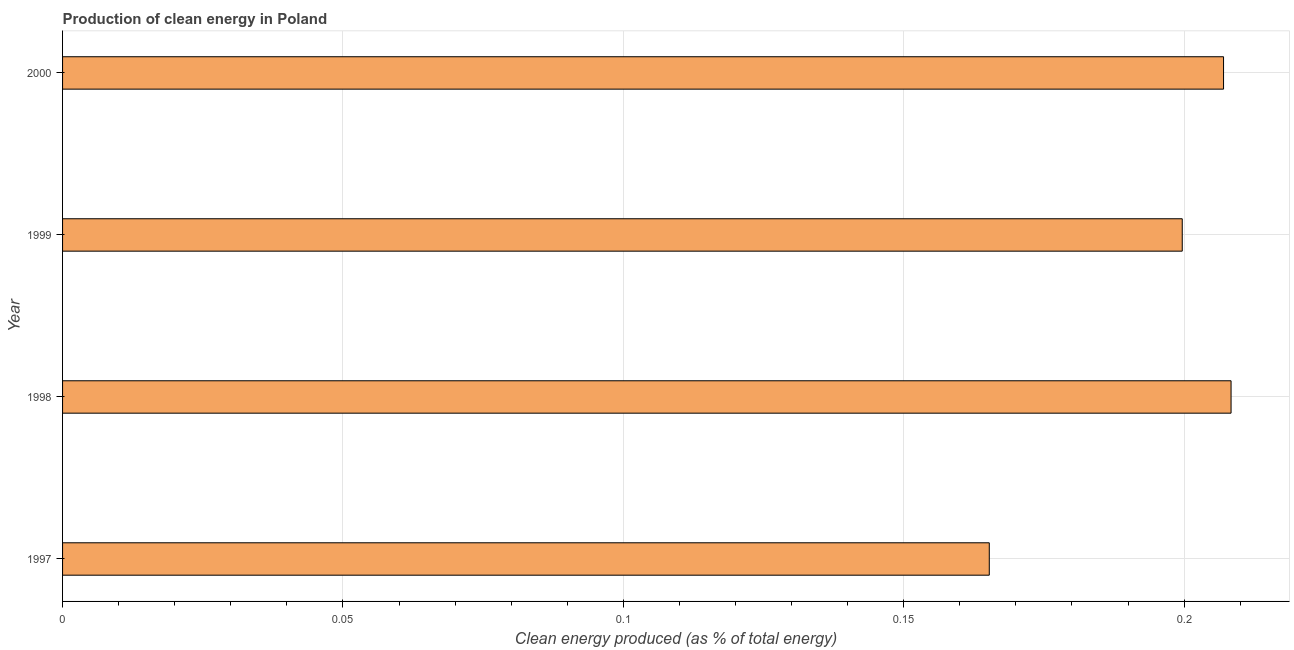Does the graph contain grids?
Make the answer very short. Yes. What is the title of the graph?
Ensure brevity in your answer.  Production of clean energy in Poland. What is the label or title of the X-axis?
Your answer should be compact. Clean energy produced (as % of total energy). What is the label or title of the Y-axis?
Provide a succinct answer. Year. What is the production of clean energy in 1998?
Your answer should be very brief. 0.21. Across all years, what is the maximum production of clean energy?
Ensure brevity in your answer.  0.21. Across all years, what is the minimum production of clean energy?
Your answer should be very brief. 0.17. In which year was the production of clean energy minimum?
Your response must be concise. 1997. What is the sum of the production of clean energy?
Make the answer very short. 0.78. What is the difference between the production of clean energy in 1999 and 2000?
Offer a terse response. -0.01. What is the average production of clean energy per year?
Give a very brief answer. 0.2. What is the median production of clean energy?
Your answer should be very brief. 0.2. In how many years, is the production of clean energy greater than 0.01 %?
Give a very brief answer. 4. Do a majority of the years between 1999 and 1997 (inclusive) have production of clean energy greater than 0.12 %?
Give a very brief answer. Yes. What is the ratio of the production of clean energy in 1997 to that in 1999?
Ensure brevity in your answer.  0.83. Is the production of clean energy in 1998 less than that in 2000?
Your response must be concise. No. Is the difference between the production of clean energy in 1997 and 1998 greater than the difference between any two years?
Offer a very short reply. Yes. In how many years, is the production of clean energy greater than the average production of clean energy taken over all years?
Offer a very short reply. 3. Are all the bars in the graph horizontal?
Your answer should be compact. Yes. How many years are there in the graph?
Your answer should be very brief. 4. What is the difference between two consecutive major ticks on the X-axis?
Your answer should be compact. 0.05. Are the values on the major ticks of X-axis written in scientific E-notation?
Keep it short and to the point. No. What is the Clean energy produced (as % of total energy) of 1997?
Keep it short and to the point. 0.17. What is the Clean energy produced (as % of total energy) of 1998?
Your response must be concise. 0.21. What is the Clean energy produced (as % of total energy) of 1999?
Make the answer very short. 0.2. What is the Clean energy produced (as % of total energy) in 2000?
Offer a terse response. 0.21. What is the difference between the Clean energy produced (as % of total energy) in 1997 and 1998?
Give a very brief answer. -0.04. What is the difference between the Clean energy produced (as % of total energy) in 1997 and 1999?
Give a very brief answer. -0.03. What is the difference between the Clean energy produced (as % of total energy) in 1997 and 2000?
Your response must be concise. -0.04. What is the difference between the Clean energy produced (as % of total energy) in 1998 and 1999?
Your response must be concise. 0.01. What is the difference between the Clean energy produced (as % of total energy) in 1998 and 2000?
Provide a short and direct response. 0. What is the difference between the Clean energy produced (as % of total energy) in 1999 and 2000?
Offer a terse response. -0.01. What is the ratio of the Clean energy produced (as % of total energy) in 1997 to that in 1998?
Give a very brief answer. 0.79. What is the ratio of the Clean energy produced (as % of total energy) in 1997 to that in 1999?
Your answer should be compact. 0.83. What is the ratio of the Clean energy produced (as % of total energy) in 1997 to that in 2000?
Provide a succinct answer. 0.8. What is the ratio of the Clean energy produced (as % of total energy) in 1998 to that in 1999?
Your response must be concise. 1.04. What is the ratio of the Clean energy produced (as % of total energy) in 1999 to that in 2000?
Make the answer very short. 0.96. 